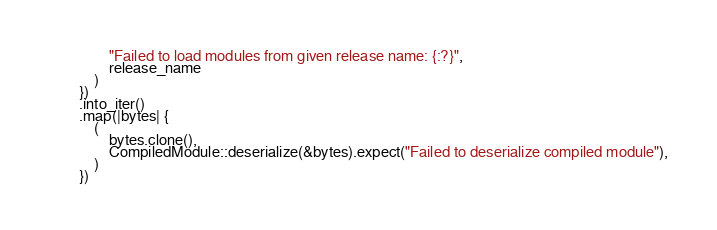<code> <loc_0><loc_0><loc_500><loc_500><_Rust_>                "Failed to load modules from given release name: {:?}",
                release_name
            )
        })
        .into_iter()
        .map(|bytes| {
            (
                bytes.clone(),
                CompiledModule::deserialize(&bytes).expect("Failed to deserialize compiled module"),
            )
        })</code> 